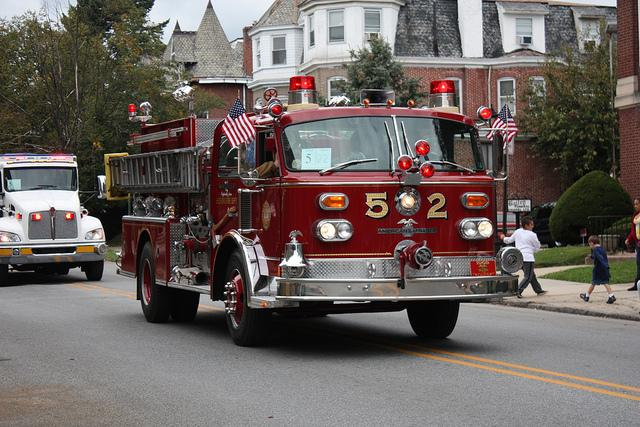What country's flag can be seen on the truck? united states 